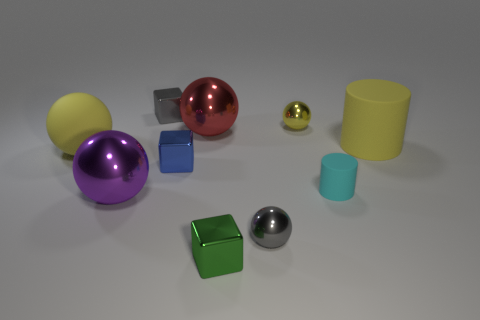Subtract all gray cylinders. Subtract all blue blocks. How many cylinders are left? 2 Subtract all cylinders. How many objects are left? 8 Add 9 blue objects. How many blue objects exist? 10 Subtract 0 red blocks. How many objects are left? 10 Subtract all brown rubber spheres. Subtract all tiny cyan matte cylinders. How many objects are left? 9 Add 3 gray objects. How many gray objects are left? 5 